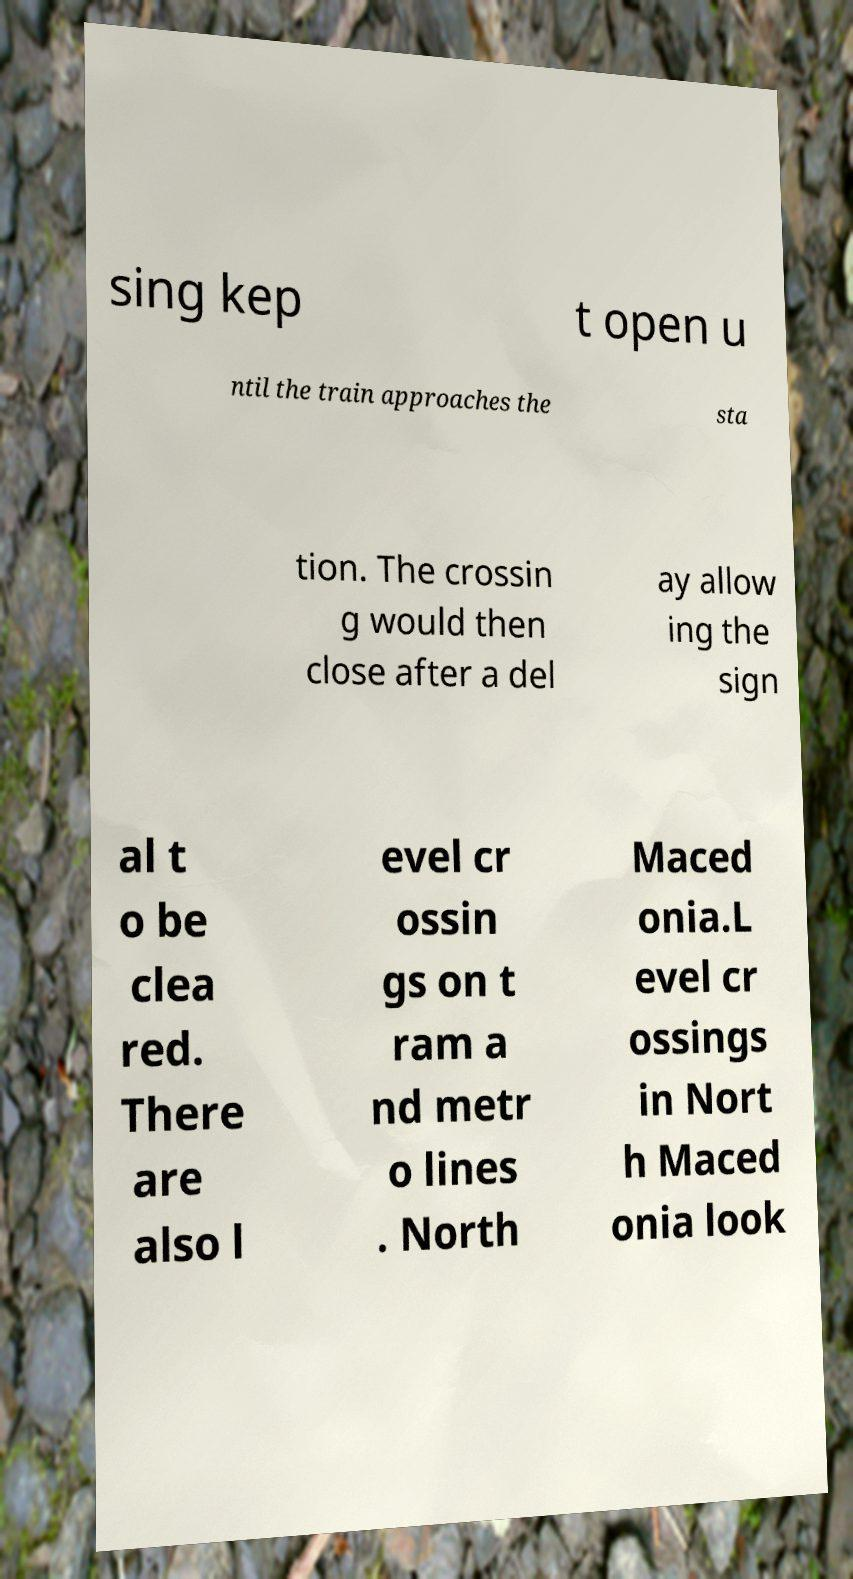Can you accurately transcribe the text from the provided image for me? sing kep t open u ntil the train approaches the sta tion. The crossin g would then close after a del ay allow ing the sign al t o be clea red. There are also l evel cr ossin gs on t ram a nd metr o lines . North Maced onia.L evel cr ossings in Nort h Maced onia look 